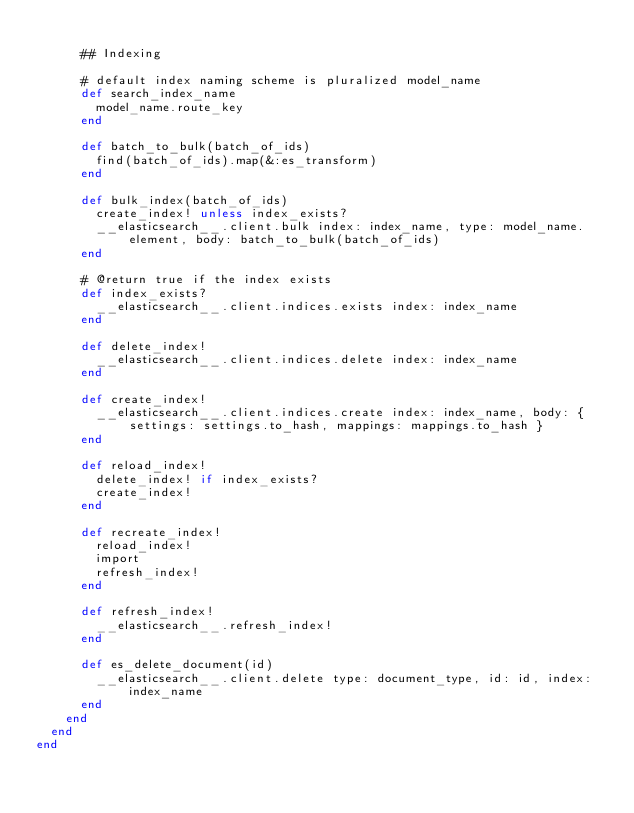<code> <loc_0><loc_0><loc_500><loc_500><_Ruby_>
      ## Indexing

      # default index naming scheme is pluralized model_name
      def search_index_name
        model_name.route_key
      end

      def batch_to_bulk(batch_of_ids)
        find(batch_of_ids).map(&:es_transform)
      end

      def bulk_index(batch_of_ids)
        create_index! unless index_exists?
        __elasticsearch__.client.bulk index: index_name, type: model_name.element, body: batch_to_bulk(batch_of_ids)
      end

      # @return true if the index exists
      def index_exists?
        __elasticsearch__.client.indices.exists index: index_name
      end

      def delete_index!
        __elasticsearch__.client.indices.delete index: index_name
      end

      def create_index!
        __elasticsearch__.client.indices.create index: index_name, body: { settings: settings.to_hash, mappings: mappings.to_hash }
      end

      def reload_index!
        delete_index! if index_exists?
        create_index!
      end

      def recreate_index!
        reload_index!
        import
        refresh_index!
      end

      def refresh_index!
        __elasticsearch__.refresh_index!
      end

      def es_delete_document(id)
        __elasticsearch__.client.delete type: document_type, id: id, index: index_name
      end
    end
  end
end
</code> 